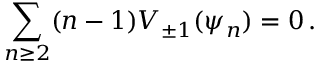Convert formula to latex. <formula><loc_0><loc_0><loc_500><loc_500>\sum _ { n \geq 2 } ( n - 1 ) V _ { \pm 1 } ( \psi _ { n } ) = 0 \, .</formula> 